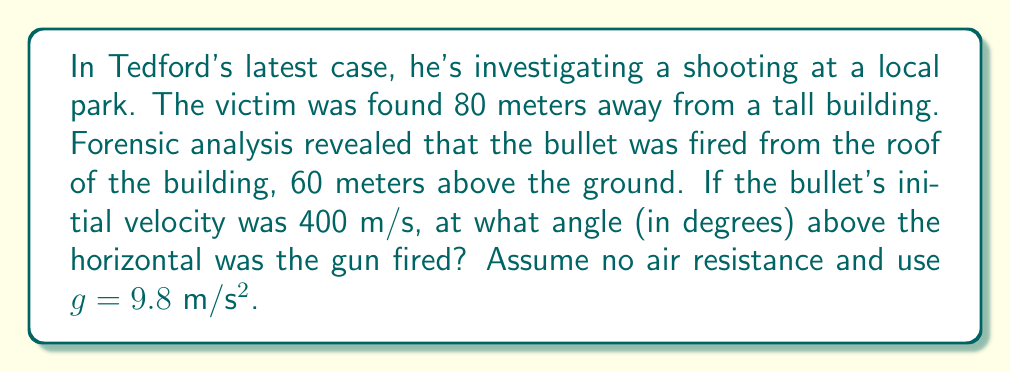Help me with this question. To solve this problem, we'll use the equations of projectile motion. Let's break it down step by step:

1) First, let's define our variables:
   $x = 80$ m (horizontal distance)
   $y = -60$ m (vertical distance, negative because the bullet goes down)
   $v_0 = 400$ m/s (initial velocity)
   $g = 9.8$ m/s² (acceleration due to gravity)
   $\theta$ = angle of trajectory (what we're solving for)

2) We can use the following equations of motion:
   $$x = (v_0 \cos\theta)t$$
   $$y = (v_0 \sin\theta)t - \frac{1}{2}gt^2$$

3) We don't know the time $t$, so we need to eliminate it. From the first equation:
   $$t = \frac{x}{v_0 \cos\theta}$$

4) Substituting this into the second equation:
   $$y = (v_0 \sin\theta)(\frac{x}{v_0 \cos\theta}) - \frac{1}{2}g(\frac{x}{v_0 \cos\theta})^2$$

5) Simplify:
   $$y = x \tan\theta - \frac{gx^2}{2(v_0 \cos\theta)^2}$$

6) Now, let's substitute our known values:
   $$-60 = 80 \tan\theta - \frac{9.8 \cdot 80^2}{2(400 \cos\theta)^2}$$

7) Multiply both sides by $\cos^2\theta$:
   $$-60\cos^2\theta = 80\sin\theta\cos\theta - \frac{9.8 \cdot 80^2}{2 \cdot 400^2} \cdot 2$$

8) Simplify:
   $$-60\cos^2\theta = 80\sin\theta\cos\theta - 0.196$$

9) Divide by $\cos^2\theta$:
   $$-60 = 80\tan\theta - \frac{0.196}{\cos^2\theta}$$

10) This equation can be solved numerically. Using a calculator or computer program, we find:
    $$\theta \approx 0.1411 \text{ radians}$$

11) Convert to degrees:
    $$\theta \approx 0.1411 \cdot \frac{180}{\pi} \approx 8.09°$$
Answer: The angle of trajectory is approximately 8.09 degrees above the horizontal. 